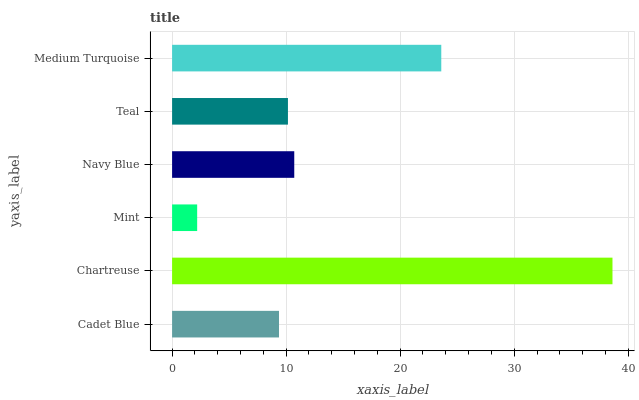Is Mint the minimum?
Answer yes or no. Yes. Is Chartreuse the maximum?
Answer yes or no. Yes. Is Chartreuse the minimum?
Answer yes or no. No. Is Mint the maximum?
Answer yes or no. No. Is Chartreuse greater than Mint?
Answer yes or no. Yes. Is Mint less than Chartreuse?
Answer yes or no. Yes. Is Mint greater than Chartreuse?
Answer yes or no. No. Is Chartreuse less than Mint?
Answer yes or no. No. Is Navy Blue the high median?
Answer yes or no. Yes. Is Teal the low median?
Answer yes or no. Yes. Is Cadet Blue the high median?
Answer yes or no. No. Is Cadet Blue the low median?
Answer yes or no. No. 